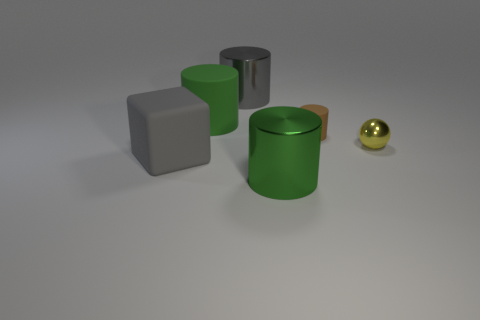Is there anything else that has the same material as the sphere?
Provide a succinct answer. Yes. Are there more tiny gray shiny things than large gray cubes?
Provide a succinct answer. No. Does the thing that is in front of the cube have the same color as the large shiny cylinder that is behind the big gray block?
Make the answer very short. No. There is a big green cylinder in front of the tiny brown matte cylinder; is there a yellow thing that is in front of it?
Your response must be concise. No. Are there fewer large green objects on the right side of the green metallic cylinder than tiny cylinders on the left side of the brown matte object?
Provide a short and direct response. No. Is the material of the big cylinder in front of the yellow sphere the same as the small object behind the yellow object?
Provide a short and direct response. No. How many tiny objects are brown rubber objects or red matte spheres?
Provide a succinct answer. 1. There is a big object that is the same material as the big gray cylinder; what is its shape?
Keep it short and to the point. Cylinder. Are there fewer green cylinders that are in front of the tiny matte cylinder than tiny yellow balls?
Your response must be concise. No. Does the green rubber thing have the same shape as the yellow metallic thing?
Offer a terse response. No. 